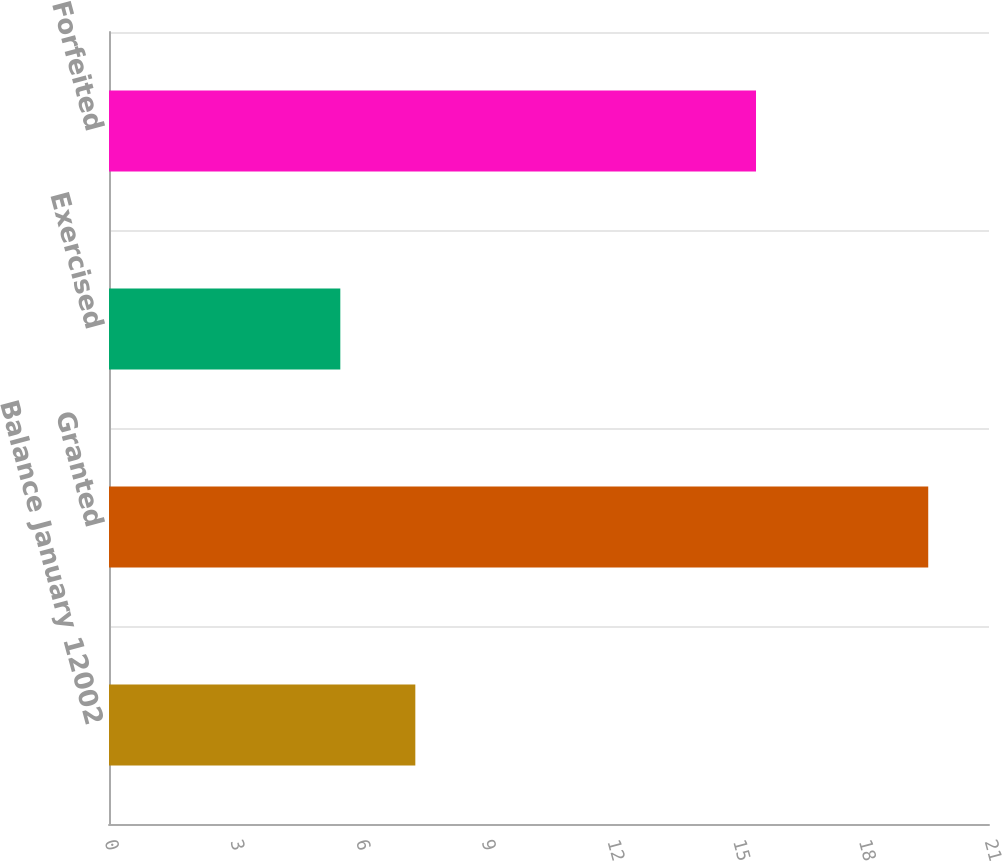<chart> <loc_0><loc_0><loc_500><loc_500><bar_chart><fcel>Balance January 12002<fcel>Granted<fcel>Exercised<fcel>Forfeited<nl><fcel>7.31<fcel>19.55<fcel>5.52<fcel>15.44<nl></chart> 